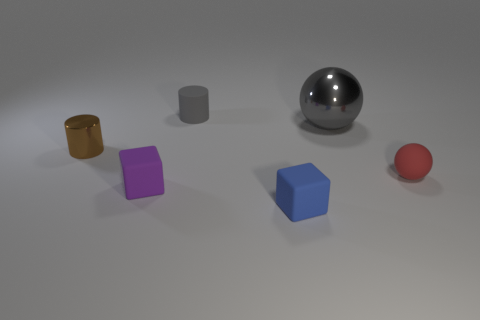Add 2 small blue blocks. How many objects exist? 8 Subtract all red balls. Subtract all green cylinders. How many balls are left? 1 Subtract all blue cubes. How many gray cylinders are left? 1 Add 3 large things. How many large things are left? 4 Add 4 small matte balls. How many small matte balls exist? 5 Subtract all purple blocks. How many blocks are left? 1 Subtract 0 purple cylinders. How many objects are left? 6 Subtract all spheres. How many objects are left? 4 Subtract all small red metallic cylinders. Subtract all matte cylinders. How many objects are left? 5 